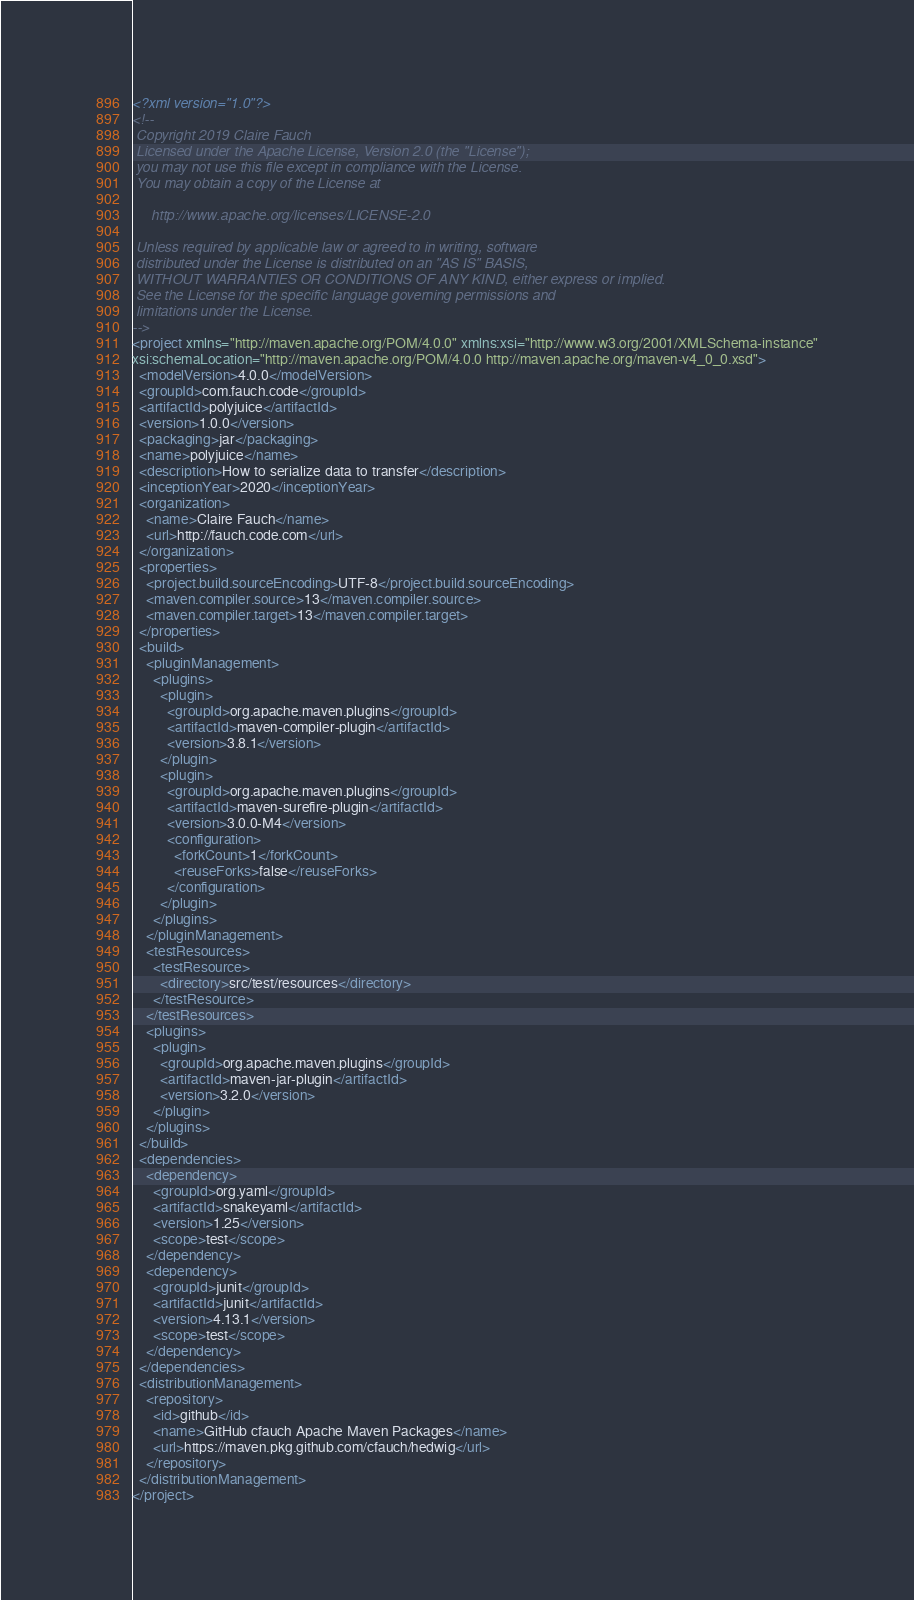<code> <loc_0><loc_0><loc_500><loc_500><_XML_><?xml version="1.0"?>
<!--
 Copyright 2019 Claire Fauch
 Licensed under the Apache License, Version 2.0 (the "License");
 you may not use this file except in compliance with the License.
 You may obtain a copy of the License at 

     http://www.apache.org/licenses/LICENSE-2.0
 
 Unless required by applicable law or agreed to in writing, software
 distributed under the License is distributed on an "AS IS" BASIS,
 WITHOUT WARRANTIES OR CONDITIONS OF ANY KIND, either express or implied.
 See the License for the specific language governing permissions and
 limitations under the License.
-->
<project xmlns="http://maven.apache.org/POM/4.0.0" xmlns:xsi="http://www.w3.org/2001/XMLSchema-instance"
xsi:schemaLocation="http://maven.apache.org/POM/4.0.0 http://maven.apache.org/maven-v4_0_0.xsd">
  <modelVersion>4.0.0</modelVersion>
  <groupId>com.fauch.code</groupId>
  <artifactId>polyjuice</artifactId>
  <version>1.0.0</version>
  <packaging>jar</packaging>
  <name>polyjuice</name>
  <description>How to serialize data to transfer</description>
  <inceptionYear>2020</inceptionYear>
  <organization>
    <name>Claire Fauch</name>
    <url>http://fauch.code.com</url>
  </organization>
  <properties>
    <project.build.sourceEncoding>UTF-8</project.build.sourceEncoding>
    <maven.compiler.source>13</maven.compiler.source>
    <maven.compiler.target>13</maven.compiler.target>
  </properties>
  <build>
    <pluginManagement>
      <plugins>
        <plugin>
          <groupId>org.apache.maven.plugins</groupId>
          <artifactId>maven-compiler-plugin</artifactId>
          <version>3.8.1</version>
        </plugin>
        <plugin>
          <groupId>org.apache.maven.plugins</groupId>
          <artifactId>maven-surefire-plugin</artifactId>
          <version>3.0.0-M4</version>
          <configuration>
            <forkCount>1</forkCount>
            <reuseForks>false</reuseForks>
          </configuration>
        </plugin>
      </plugins>
    </pluginManagement>
    <testResources>
      <testResource>
        <directory>src/test/resources</directory>
      </testResource>
    </testResources>
    <plugins>
      <plugin>
        <groupId>org.apache.maven.plugins</groupId>
        <artifactId>maven-jar-plugin</artifactId>
        <version>3.2.0</version>
      </plugin>
    </plugins>
  </build>
  <dependencies>
    <dependency>
      <groupId>org.yaml</groupId>
      <artifactId>snakeyaml</artifactId>
      <version>1.25</version>
      <scope>test</scope>
    </dependency>
    <dependency>
      <groupId>junit</groupId>
      <artifactId>junit</artifactId>
      <version>4.13.1</version>
      <scope>test</scope>
    </dependency>
  </dependencies>
  <distributionManagement>
    <repository>
      <id>github</id>
      <name>GitHub cfauch Apache Maven Packages</name>
      <url>https://maven.pkg.github.com/cfauch/hedwig</url>
    </repository>
  </distributionManagement>
</project>
</code> 